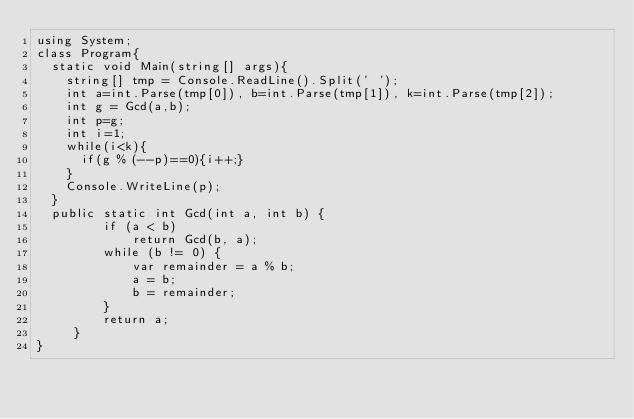Convert code to text. <code><loc_0><loc_0><loc_500><loc_500><_C#_>using System;
class Program{
  static void Main(string[] args){
    string[] tmp = Console.ReadLine().Split(' ');
    int a=int.Parse(tmp[0]), b=int.Parse(tmp[1]), k=int.Parse(tmp[2]);
    int g = Gcd(a,b);
    int p=g;
    int i=1;
    while(i<k){
      if(g % (--p)==0){i++;}
    }
    Console.WriteLine(p);
  }
  public static int Gcd(int a, int b) {
         if (a < b)
             return Gcd(b, a);
         while (b != 0) {
             var remainder = a % b;
             a = b;
             b = remainder;
         }
         return a;
     }
}</code> 